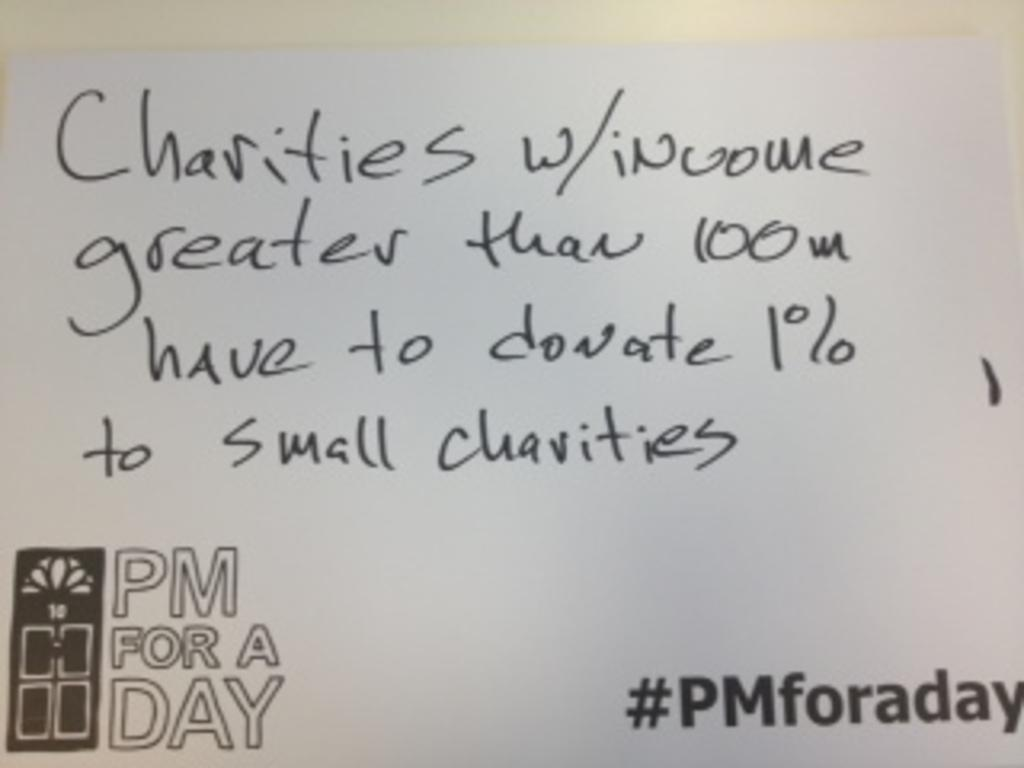What is present on the paper in the image? There is text on a paper in the image. What color is the text on the paper? The text is black in color. What color is the paper itself? The paper is white in color. What type of apparel is being worn by the text on the paper? The text on the paper is not a person or an object that can wear apparel; it is simply text on a paper. What type of pen was used to write the text on the paper? There is no information provided about the pen used to write the text on the paper. How many pies are visible in the image? There are no pies present in the image. 